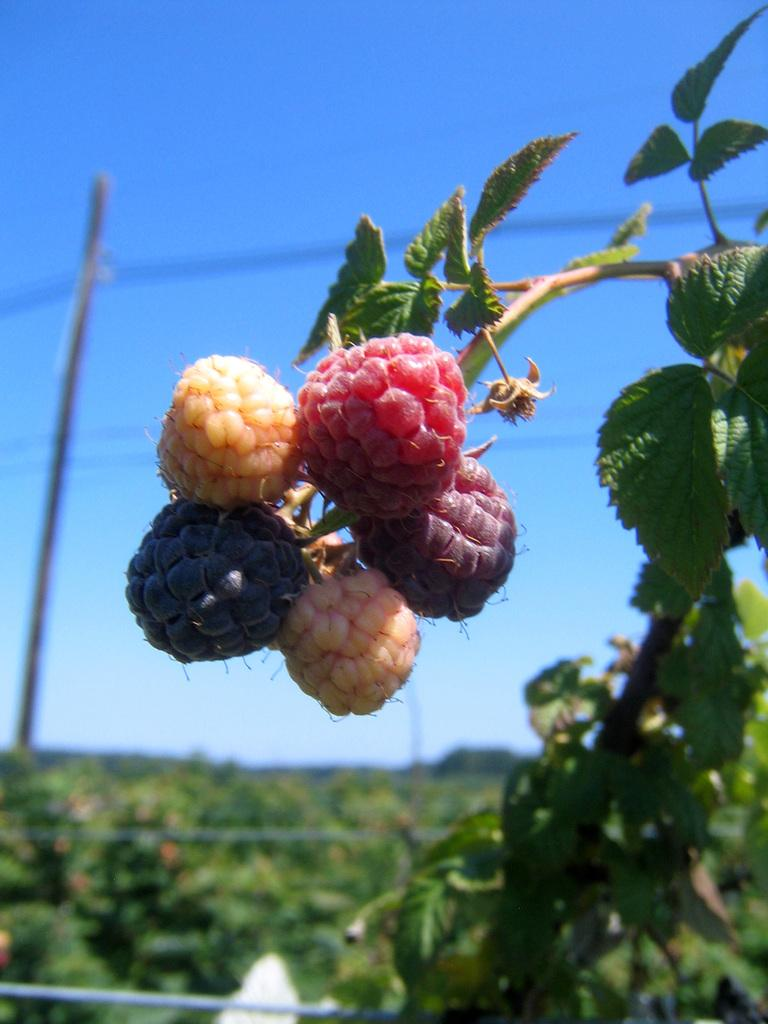What is the color of the sky in the background of the image? The sky in the background of the image is clear blue. What can be seen in the background of the image besides the sky? There is a pole and wires visible in the background of the image. What type of vegetation is visible at the bottom portion of the image? There is greenery visible at the bottom portion of the image. What is present on the right side of the image? There are berries and green leaves on the right side of the image. Who is the creator of the force field visible in the image? There is no force field present in the image. 